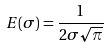<formula> <loc_0><loc_0><loc_500><loc_500>E ( \sigma ) = \frac { 1 } { 2 \sigma \sqrt { \pi } }</formula> 